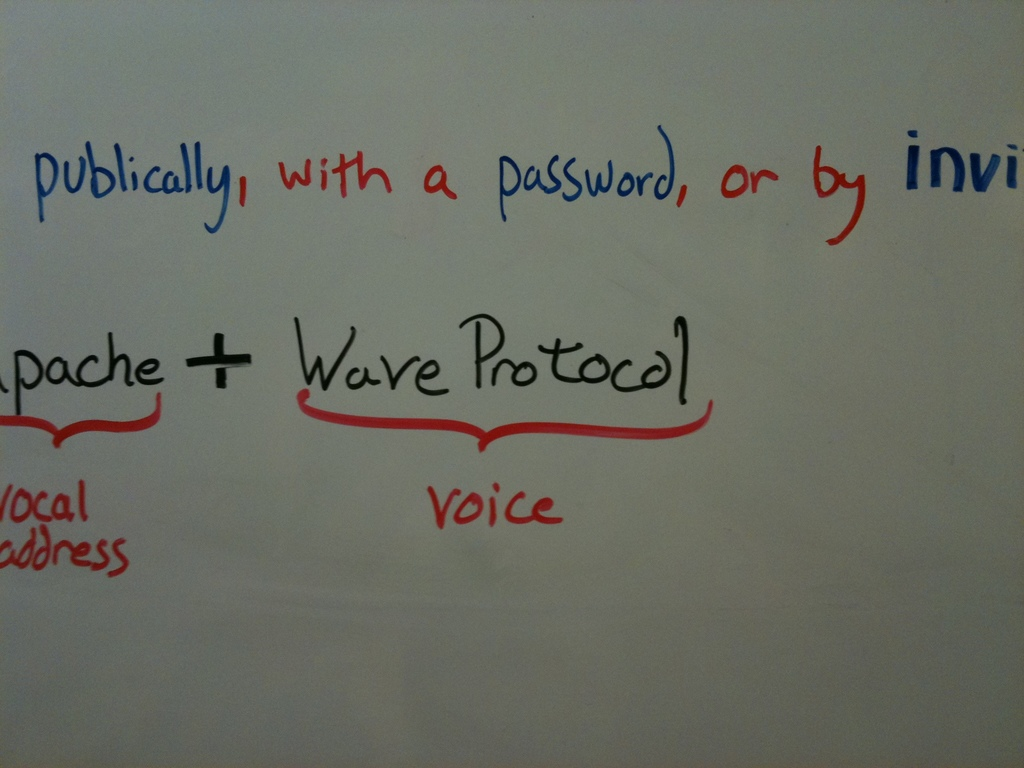Can you explain more about what the 'Apache Wave Protocol' is and its significance in technology? The Apache Wave Protocol is an open-source project originally developed by Google as Google Wave. It was designed to support real-time collaborative editing online, where multiple users can edit the same document simultaneously and see each other's changes in real-time. It's significant in technology as it pioneers discussions and developments in real-time collaboration tools, a vital aspect for enhancing user interaction and productivity in various digital workspaces. 